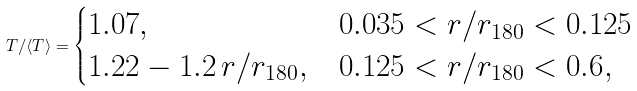Convert formula to latex. <formula><loc_0><loc_0><loc_500><loc_500>T / \langle T \rangle = \begin{cases} 1 . 0 7 , & \text {$0.035 < r/r_{180} < 0.125$} \\ 1 . 2 2 - 1 . 2 \, r / r _ { 1 8 0 } , & \text {$0.125 < r/r_{180} < 0.6$} , \end{cases}</formula> 